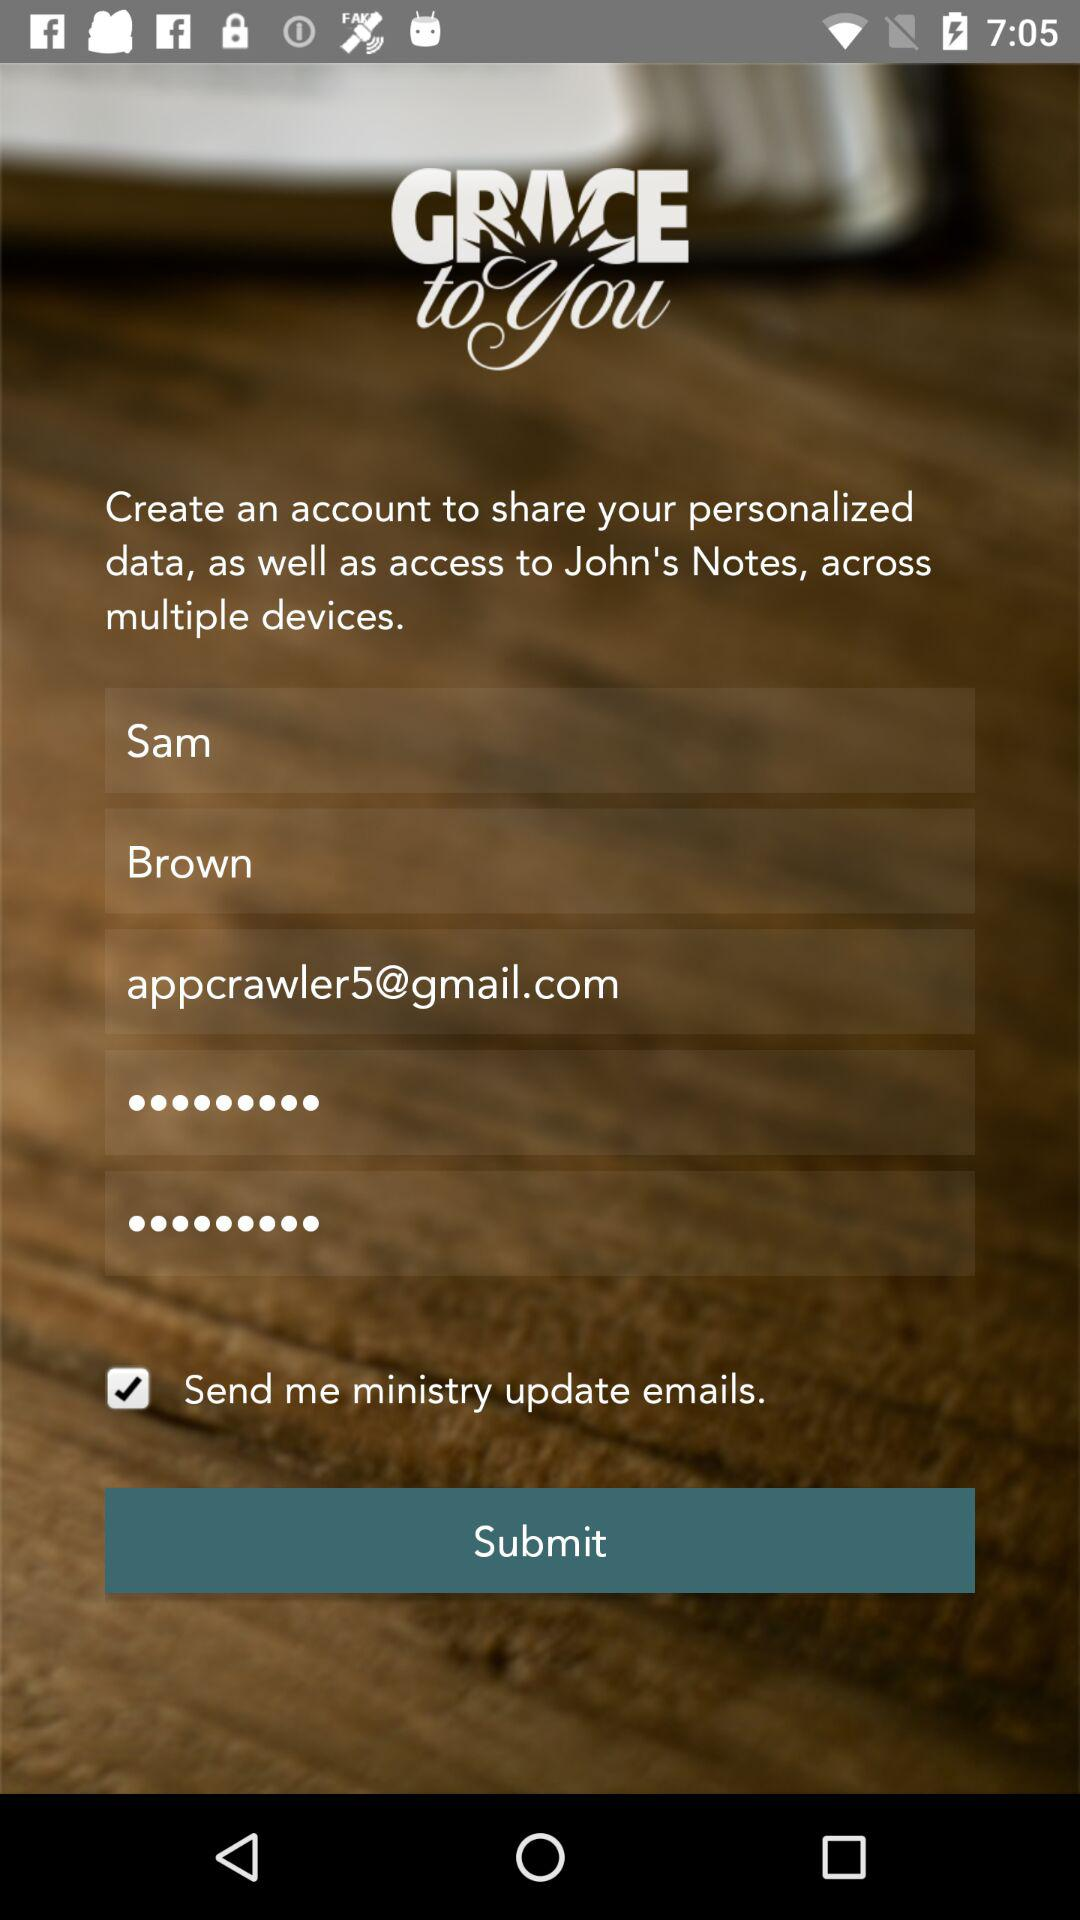What is the name of the application? The name of the application is "GRACE to you". 